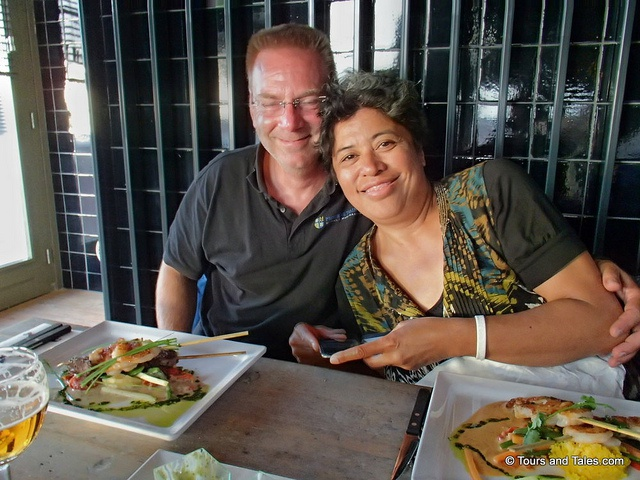Describe the objects in this image and their specific colors. I can see dining table in lightblue, gray, darkgray, and olive tones, people in lightblue, black, brown, and maroon tones, people in lightblue, black, gray, lightpink, and maroon tones, wine glass in lightblue, darkgray, lightgray, orange, and tan tones, and knife in lightblue, black, maroon, gray, and brown tones in this image. 